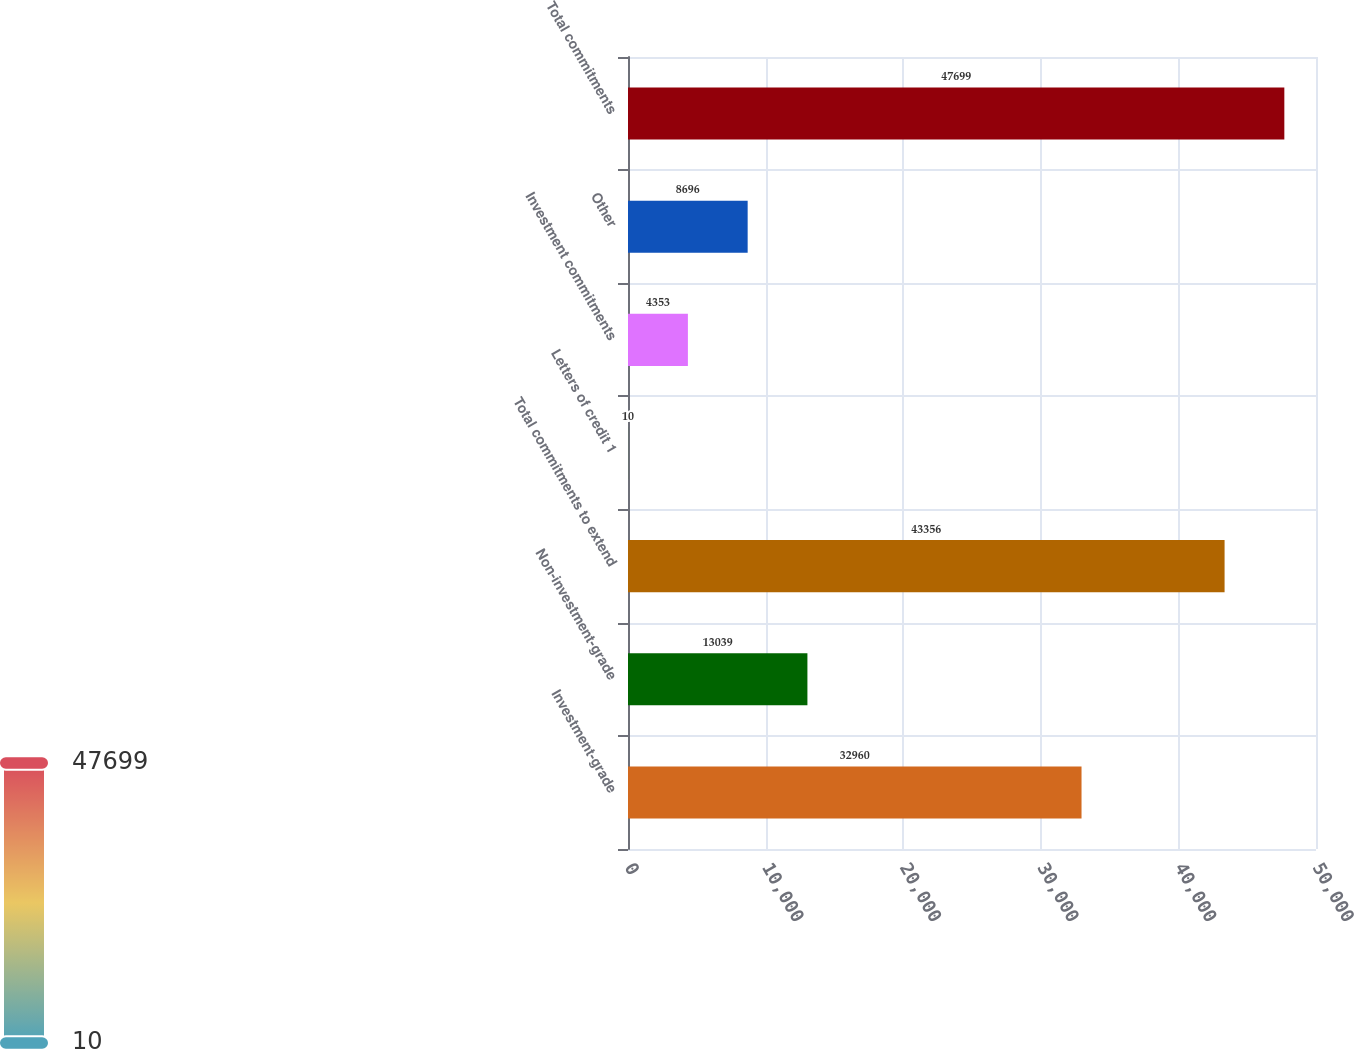<chart> <loc_0><loc_0><loc_500><loc_500><bar_chart><fcel>Investment-grade<fcel>Non-investment-grade<fcel>Total commitments to extend<fcel>Letters of credit 1<fcel>Investment commitments<fcel>Other<fcel>Total commitments<nl><fcel>32960<fcel>13039<fcel>43356<fcel>10<fcel>4353<fcel>8696<fcel>47699<nl></chart> 